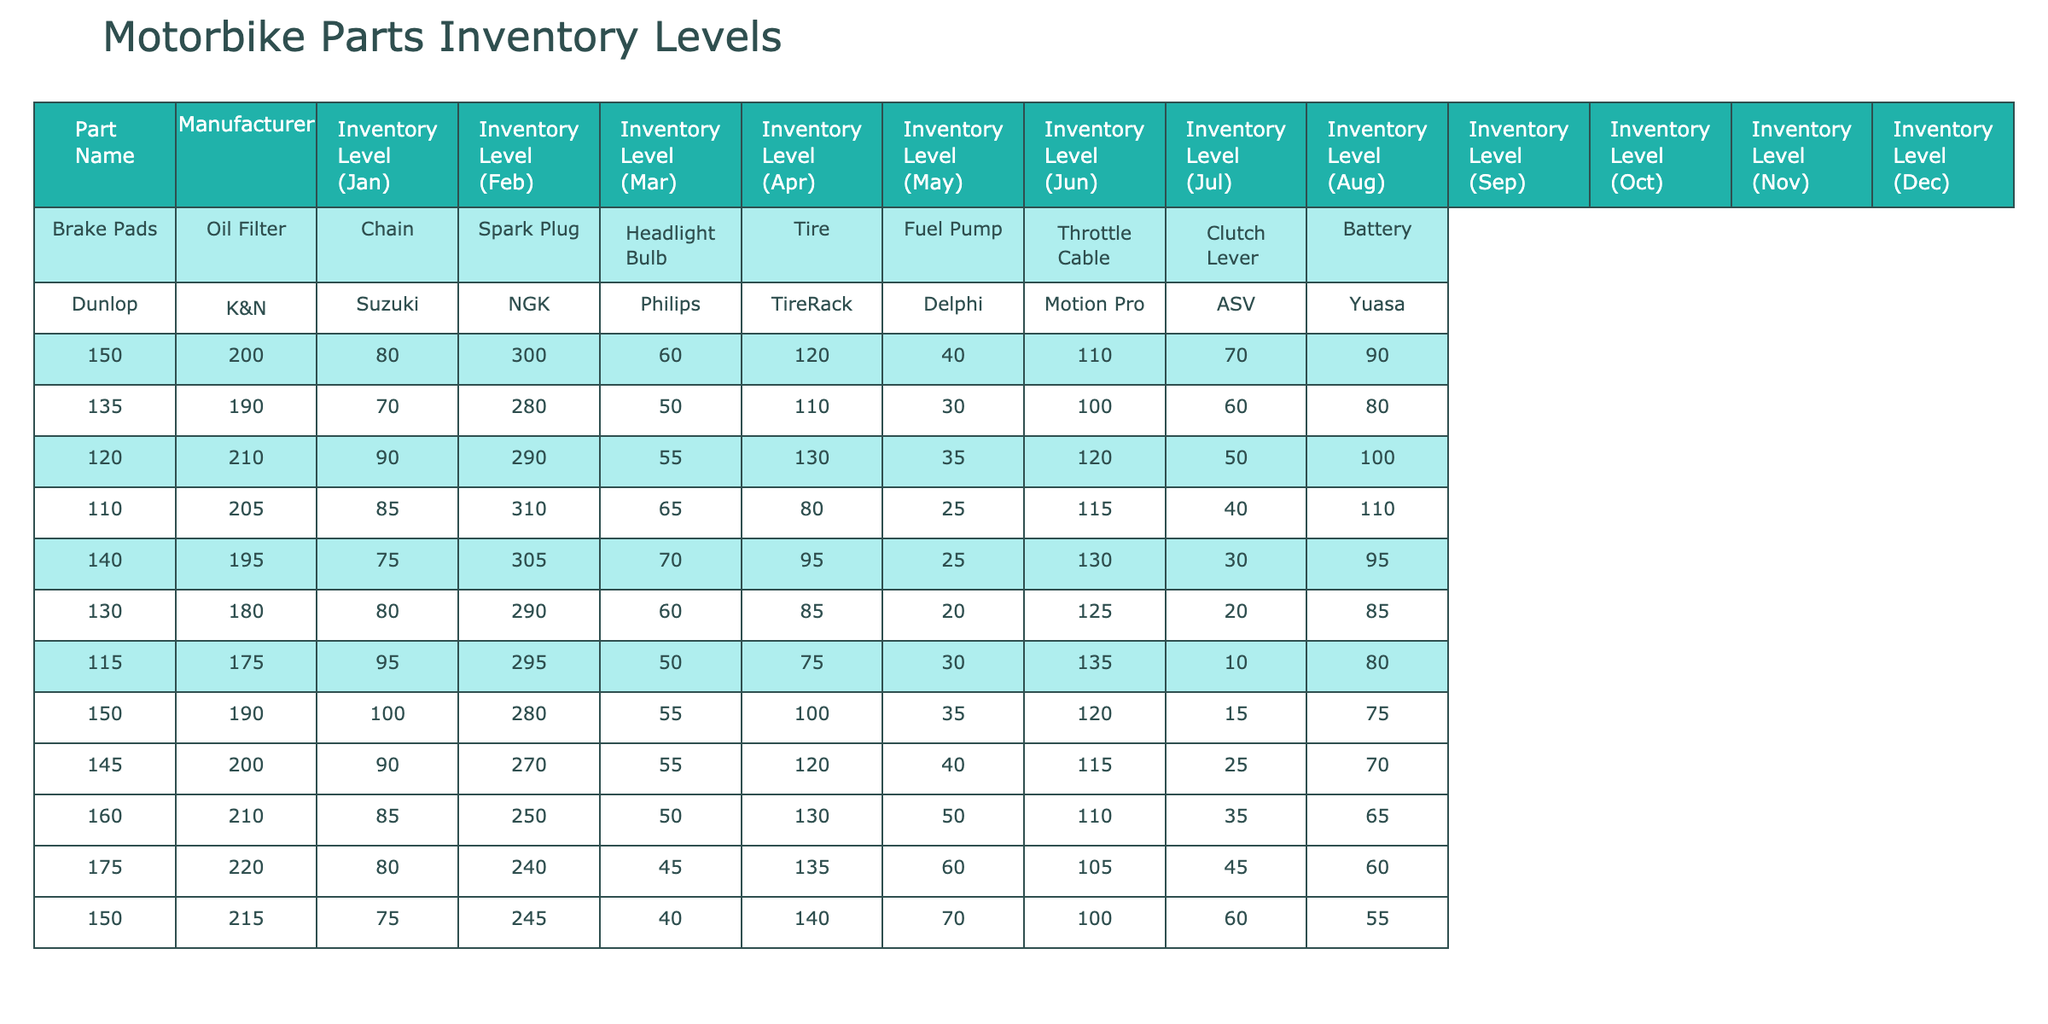What is the inventory level of Brake Pads in December? The inventory level of Brake Pads in December is directly stated in the table, which shows 150 as the inventory level for that month.
Answer: 150 Which part had the highest inventory level in March? Looking at the March inventory levels, the part with the highest level is the Spark Plug, which shows 290 as its inventory.
Answer: Spark Plug What is the average inventory level of Oil Filters over the year? To find the average inventory level for Oil Filters, add all the monthly values: (200 + 190 + 210 + 205 + 195 + 180 + 175 + 190 + 200 + 210 + 220 + 215) = 2,340. There are 12 months, so the average is 2,340 / 12 = 195.
Answer: 195 Did the inventory level of Clutch Levers increase from November to December? The inventory level of Clutch Levers in November is 45, and in December, it is 60. Since 60 is greater than 45, it indicates an increase.
Answer: Yes What was the change in inventory level for the Tire from January to April? In January, the inventory level of Tire is 120, and in April, it is 80. The change is 80 - 120 = -40, which indicates a decrease in inventory.
Answer: Decrease of 40 Which part had the lowest inventory level on average over the last year? To find the part with the lowest average inventory level, we compute the averages for each part. The Brake Pads average (approximately 138.33) is higher than the Clutch Lever average (50). Thus, the Clutch Lever has the lowest average inventory over the year.
Answer: Clutch Lever What was the difference in inventory levels of Battery between January and December? The inventory level of the Battery in January is 90 and in December is 55. The difference is 55 - 90 = -35, indicating a decrease in inventory.
Answer: Decrease of 35 Which part's inventory level fluctuated the most throughout the year? By examining the monthly levels for each part, it is evident that Spark Plug had varying levels going from 300 down to 240. The maximum change is from 300 to 240, a difference of 60. Thus, it shows the most fluctuation.
Answer: Spark Plug Is the inventory level of Fuel Pumps greater than 50 in any month? Upon reviewing the inventory levels for Fuel Pumps, it is noted that they are below 50 in the months of January to June and only exceed 50 in the months of September to December.
Answer: Yes In which month did the Tire reach its minimum inventory level? Looking through the Tire inventory, the lowest level appears in April, where it shows 80. This is less than the levels in the other months, indicating it's the minimum for Tire inventory.
Answer: April 